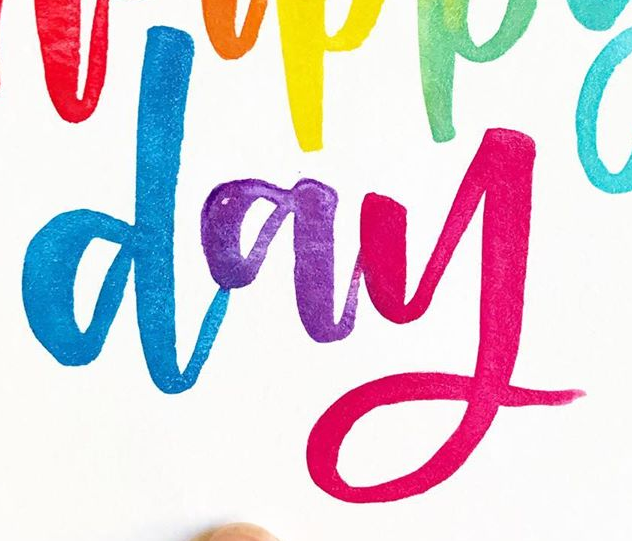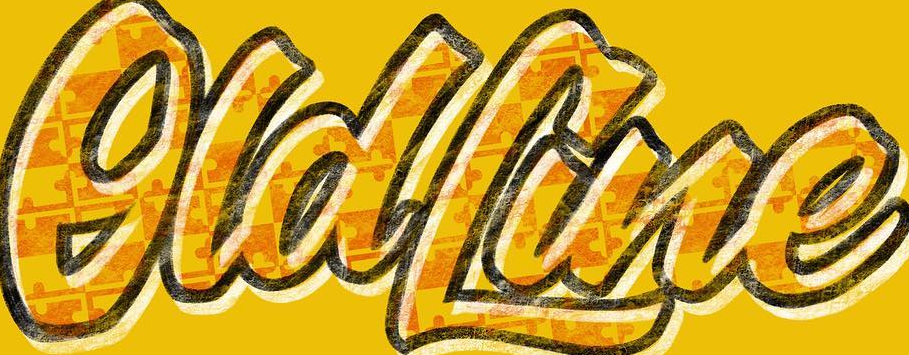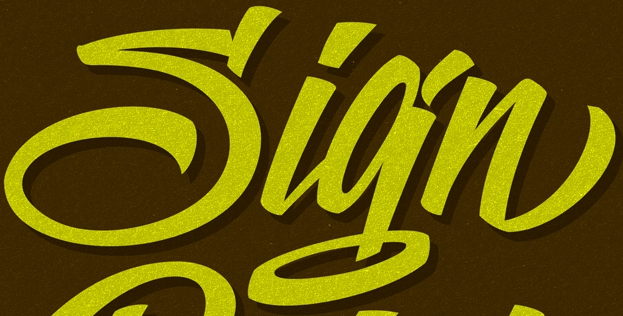Read the text from these images in sequence, separated by a semicolon. day; OldLine; Sign 